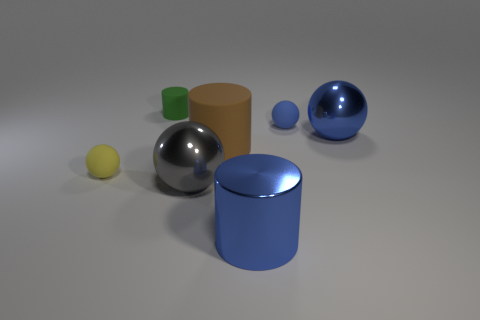There is a yellow thing; is it the same size as the metal object that is to the left of the blue shiny cylinder?
Make the answer very short. No. There is a metal ball that is the same color as the metallic cylinder; what is its size?
Your response must be concise. Large. Do the blue cylinder and the green matte thing have the same size?
Offer a terse response. No. There is a blue shiny object that is in front of the big blue metallic ball; what number of shiny cylinders are right of it?
Ensure brevity in your answer.  0. Does the large brown thing have the same shape as the green matte thing?
Provide a short and direct response. Yes. There is another metallic object that is the same shape as the large gray metallic thing; what size is it?
Your answer should be compact. Large. There is a thing that is in front of the big object on the left side of the large brown cylinder; what shape is it?
Your response must be concise. Cylinder. What size is the blue metallic ball?
Offer a terse response. Large. There is a big brown rubber thing; what shape is it?
Make the answer very short. Cylinder. There is a small yellow matte object; is it the same shape as the small object right of the gray thing?
Ensure brevity in your answer.  Yes. 